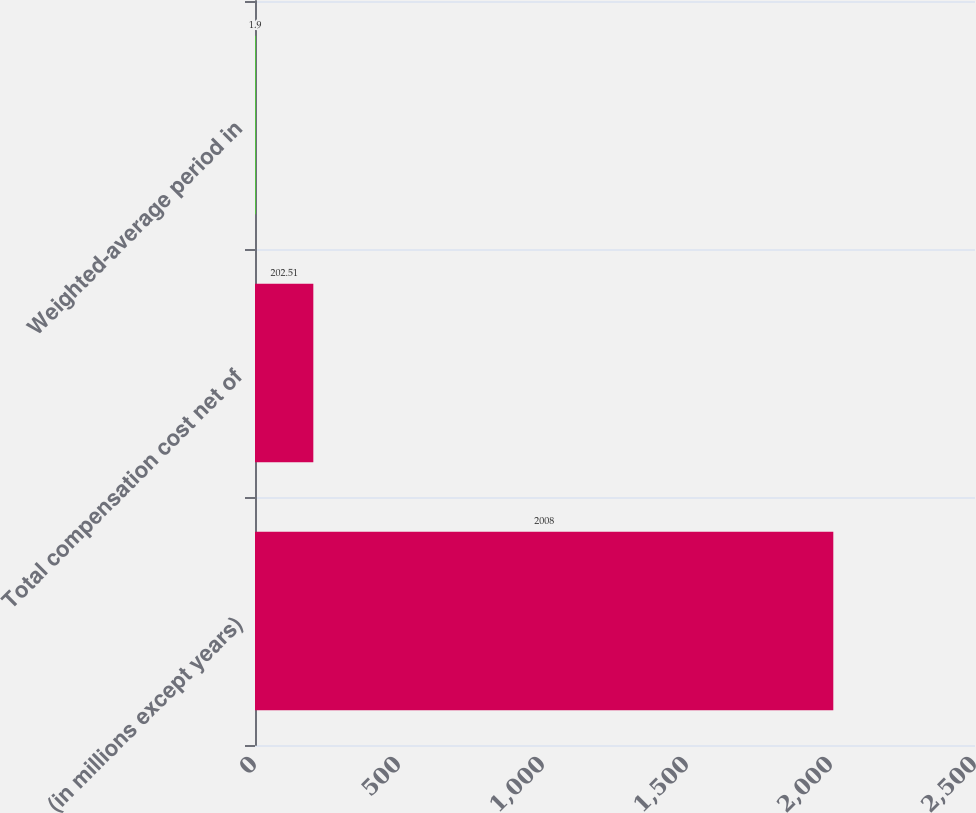Convert chart. <chart><loc_0><loc_0><loc_500><loc_500><bar_chart><fcel>(in millions except years)<fcel>Total compensation cost net of<fcel>Weighted-average period in<nl><fcel>2008<fcel>202.51<fcel>1.9<nl></chart> 